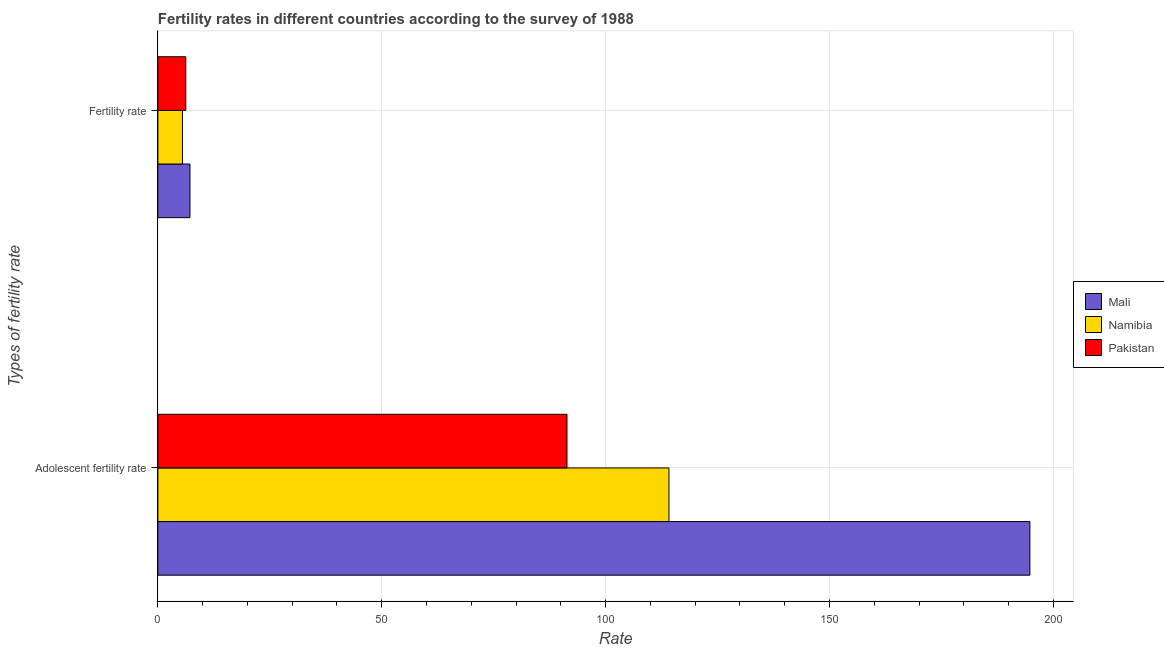Are the number of bars per tick equal to the number of legend labels?
Your response must be concise. Yes. Are the number of bars on each tick of the Y-axis equal?
Keep it short and to the point. Yes. How many bars are there on the 1st tick from the bottom?
Provide a succinct answer. 3. What is the label of the 2nd group of bars from the top?
Your answer should be compact. Adolescent fertility rate. What is the adolescent fertility rate in Pakistan?
Offer a terse response. 91.37. Across all countries, what is the maximum adolescent fertility rate?
Provide a succinct answer. 194.76. Across all countries, what is the minimum fertility rate?
Your answer should be very brief. 5.49. In which country was the fertility rate maximum?
Offer a terse response. Mali. In which country was the fertility rate minimum?
Give a very brief answer. Namibia. What is the total fertility rate in the graph?
Make the answer very short. 18.89. What is the difference between the adolescent fertility rate in Mali and that in Pakistan?
Keep it short and to the point. 103.39. What is the difference between the fertility rate in Namibia and the adolescent fertility rate in Mali?
Offer a very short reply. -189.27. What is the average fertility rate per country?
Ensure brevity in your answer.  6.3. What is the difference between the fertility rate and adolescent fertility rate in Pakistan?
Provide a succinct answer. -85.14. In how many countries, is the adolescent fertility rate greater than 70 ?
Provide a short and direct response. 3. What is the ratio of the adolescent fertility rate in Pakistan to that in Namibia?
Provide a succinct answer. 0.8. What does the 2nd bar from the top in Fertility rate represents?
Provide a succinct answer. Namibia. What does the 3rd bar from the bottom in Adolescent fertility rate represents?
Provide a short and direct response. Pakistan. How many bars are there?
Your answer should be very brief. 6. What is the difference between two consecutive major ticks on the X-axis?
Ensure brevity in your answer.  50. Are the values on the major ticks of X-axis written in scientific E-notation?
Your answer should be compact. No. Does the graph contain any zero values?
Provide a short and direct response. No. How many legend labels are there?
Your answer should be very brief. 3. What is the title of the graph?
Provide a short and direct response. Fertility rates in different countries according to the survey of 1988. Does "Rwanda" appear as one of the legend labels in the graph?
Provide a short and direct response. No. What is the label or title of the X-axis?
Offer a very short reply. Rate. What is the label or title of the Y-axis?
Offer a very short reply. Types of fertility rate. What is the Rate in Mali in Adolescent fertility rate?
Keep it short and to the point. 194.76. What is the Rate of Namibia in Adolescent fertility rate?
Your response must be concise. 114.15. What is the Rate in Pakistan in Adolescent fertility rate?
Make the answer very short. 91.37. What is the Rate in Mali in Fertility rate?
Your answer should be very brief. 7.16. What is the Rate in Namibia in Fertility rate?
Provide a short and direct response. 5.49. What is the Rate of Pakistan in Fertility rate?
Offer a terse response. 6.23. Across all Types of fertility rate, what is the maximum Rate of Mali?
Provide a short and direct response. 194.76. Across all Types of fertility rate, what is the maximum Rate of Namibia?
Provide a short and direct response. 114.15. Across all Types of fertility rate, what is the maximum Rate in Pakistan?
Offer a very short reply. 91.37. Across all Types of fertility rate, what is the minimum Rate of Mali?
Offer a very short reply. 7.16. Across all Types of fertility rate, what is the minimum Rate of Namibia?
Your answer should be very brief. 5.49. Across all Types of fertility rate, what is the minimum Rate of Pakistan?
Ensure brevity in your answer.  6.23. What is the total Rate in Mali in the graph?
Your response must be concise. 201.92. What is the total Rate of Namibia in the graph?
Your response must be concise. 119.64. What is the total Rate of Pakistan in the graph?
Offer a terse response. 97.61. What is the difference between the Rate in Mali in Adolescent fertility rate and that in Fertility rate?
Give a very brief answer. 187.6. What is the difference between the Rate in Namibia in Adolescent fertility rate and that in Fertility rate?
Your response must be concise. 108.65. What is the difference between the Rate of Pakistan in Adolescent fertility rate and that in Fertility rate?
Provide a short and direct response. 85.14. What is the difference between the Rate in Mali in Adolescent fertility rate and the Rate in Namibia in Fertility rate?
Give a very brief answer. 189.27. What is the difference between the Rate of Mali in Adolescent fertility rate and the Rate of Pakistan in Fertility rate?
Offer a terse response. 188.53. What is the difference between the Rate in Namibia in Adolescent fertility rate and the Rate in Pakistan in Fertility rate?
Your response must be concise. 107.91. What is the average Rate of Mali per Types of fertility rate?
Offer a terse response. 100.96. What is the average Rate in Namibia per Types of fertility rate?
Provide a short and direct response. 59.82. What is the average Rate in Pakistan per Types of fertility rate?
Make the answer very short. 48.8. What is the difference between the Rate in Mali and Rate in Namibia in Adolescent fertility rate?
Provide a short and direct response. 80.62. What is the difference between the Rate of Mali and Rate of Pakistan in Adolescent fertility rate?
Your answer should be very brief. 103.39. What is the difference between the Rate of Namibia and Rate of Pakistan in Adolescent fertility rate?
Provide a short and direct response. 22.77. What is the difference between the Rate of Mali and Rate of Namibia in Fertility rate?
Your answer should be compact. 1.67. What is the difference between the Rate in Mali and Rate in Pakistan in Fertility rate?
Your answer should be compact. 0.93. What is the difference between the Rate of Namibia and Rate of Pakistan in Fertility rate?
Ensure brevity in your answer.  -0.74. What is the ratio of the Rate of Mali in Adolescent fertility rate to that in Fertility rate?
Offer a very short reply. 27.2. What is the ratio of the Rate in Namibia in Adolescent fertility rate to that in Fertility rate?
Keep it short and to the point. 20.79. What is the ratio of the Rate of Pakistan in Adolescent fertility rate to that in Fertility rate?
Offer a very short reply. 14.66. What is the difference between the highest and the second highest Rate of Mali?
Your response must be concise. 187.6. What is the difference between the highest and the second highest Rate in Namibia?
Give a very brief answer. 108.65. What is the difference between the highest and the second highest Rate in Pakistan?
Offer a very short reply. 85.14. What is the difference between the highest and the lowest Rate in Mali?
Provide a short and direct response. 187.6. What is the difference between the highest and the lowest Rate in Namibia?
Give a very brief answer. 108.65. What is the difference between the highest and the lowest Rate in Pakistan?
Keep it short and to the point. 85.14. 